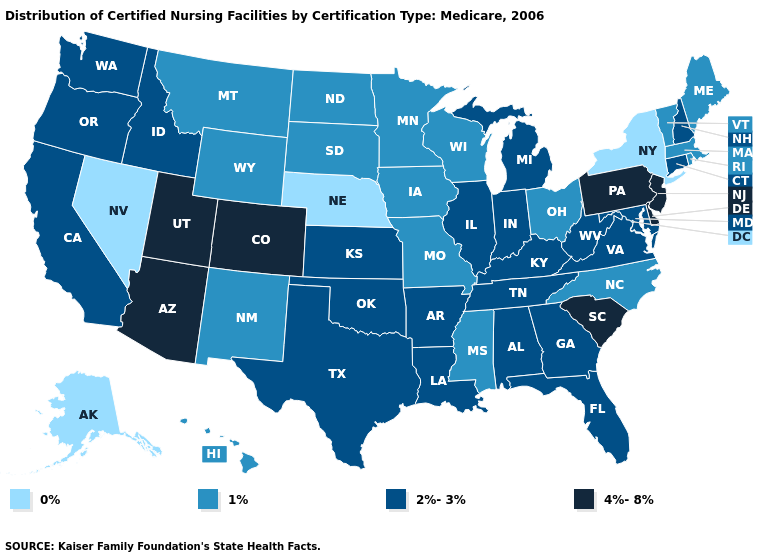What is the highest value in states that border Virginia?
Quick response, please. 2%-3%. Which states hav the highest value in the South?
Be succinct. Delaware, South Carolina. Name the states that have a value in the range 0%?
Be succinct. Alaska, Nebraska, Nevada, New York. Name the states that have a value in the range 1%?
Give a very brief answer. Hawaii, Iowa, Maine, Massachusetts, Minnesota, Mississippi, Missouri, Montana, New Mexico, North Carolina, North Dakota, Ohio, Rhode Island, South Dakota, Vermont, Wisconsin, Wyoming. Name the states that have a value in the range 4%-8%?
Be succinct. Arizona, Colorado, Delaware, New Jersey, Pennsylvania, South Carolina, Utah. What is the lowest value in states that border West Virginia?
Write a very short answer. 1%. Does Wyoming have the highest value in the USA?
Be succinct. No. What is the value of Massachusetts?
Give a very brief answer. 1%. Which states have the highest value in the USA?
Concise answer only. Arizona, Colorado, Delaware, New Jersey, Pennsylvania, South Carolina, Utah. Name the states that have a value in the range 0%?
Answer briefly. Alaska, Nebraska, Nevada, New York. Does Pennsylvania have the highest value in the USA?
Write a very short answer. Yes. Does Illinois have the highest value in the MidWest?
Quick response, please. Yes. What is the value of Rhode Island?
Answer briefly. 1%. Does New York have the lowest value in the Northeast?
Be succinct. Yes. Name the states that have a value in the range 2%-3%?
Keep it brief. Alabama, Arkansas, California, Connecticut, Florida, Georgia, Idaho, Illinois, Indiana, Kansas, Kentucky, Louisiana, Maryland, Michigan, New Hampshire, Oklahoma, Oregon, Tennessee, Texas, Virginia, Washington, West Virginia. 